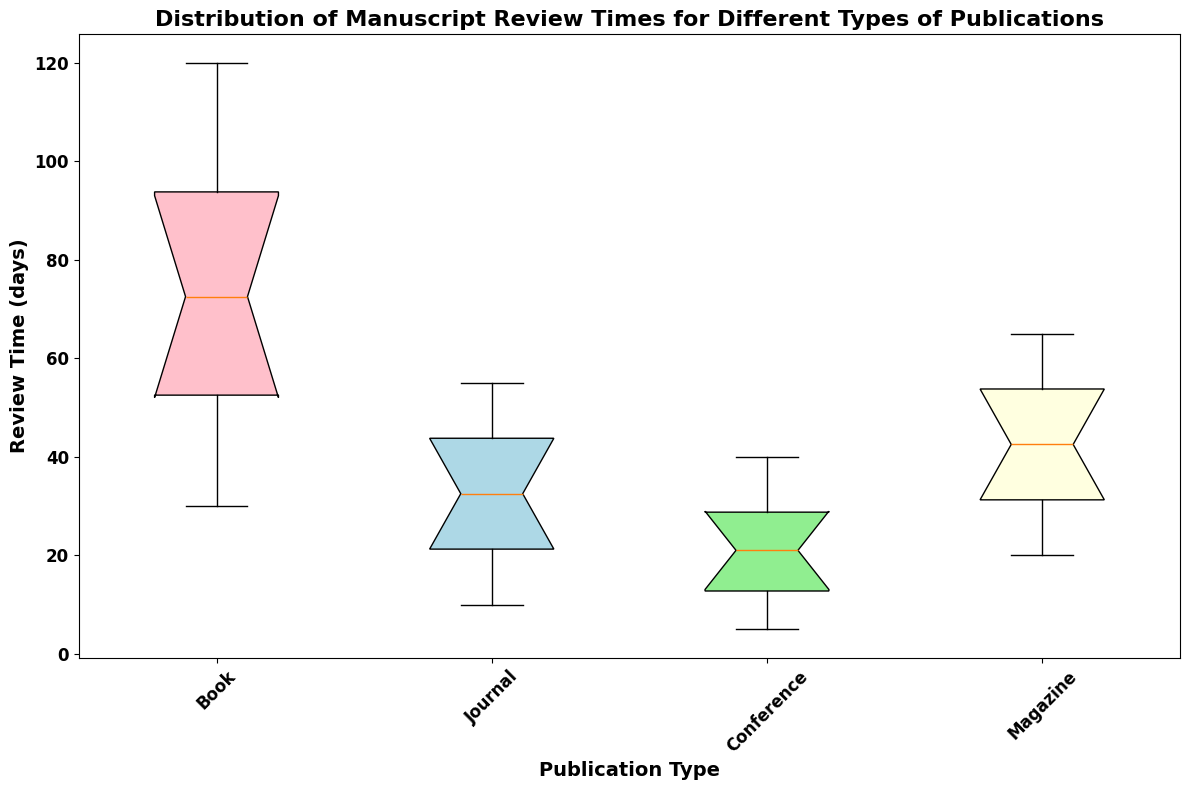What is the median review time for Books? The median review time for Books is observed from the middle line inside the box plot for Books.
Answer: 75 Which publication type has the shortest minimum review time? The minimum review time is indicated by the bottom whisker of each box plot. The shortest minimum review time is for Conferences.
Answer: Conference Which publication type has the widest interquartile range for review times? The interquartile range (IQR) is indicated by the height of the box. The box for Books has the widest IQR among all publication types.
Answer: Book What is the range of review times for Journals? The range of review times for Journals is from the bottom whisker to the top whisker, which ranges from 10 to 55 days.
Answer: 10 to 55 days Compare the medians of Conference and Magazine review times. The median for Conferences is indicated by the middle line of the Conference box and for Magazines by the middle line of the Magazine box. The median for Conferences is around 20 days, while for Magazines it is around 45 days.
Answer: Conference: 20, Magazine: 45 Which publication type shows the most consistency in review times based on the interquartile range? Consistency can be gauged by the smallest interquartile range, which is indicated by the height of the box. The Journal box is the smallest, indicating most consistency.
Answer: Journal Are there any publication types with outliers in review times? Outliers are shown as individual points outside the whiskers of the box plots. None of the publication types have points outside the whiskers, so there are no outliers.
Answer: None What color is used for the box representing Magazine review times, and how does this compare visually to the color used for Books? The boxes for Magazines are light yellow, while those for Books are pink.
Answer: Magazine: light yellow, Book: pink Order the publication types from the shortest to the longest median review time. The median review time is shown by the middle line in each box. Ordering them gives: Conference < Journal < Magazine < Book.
Answer: Conference, Journal, Magazine, Book 